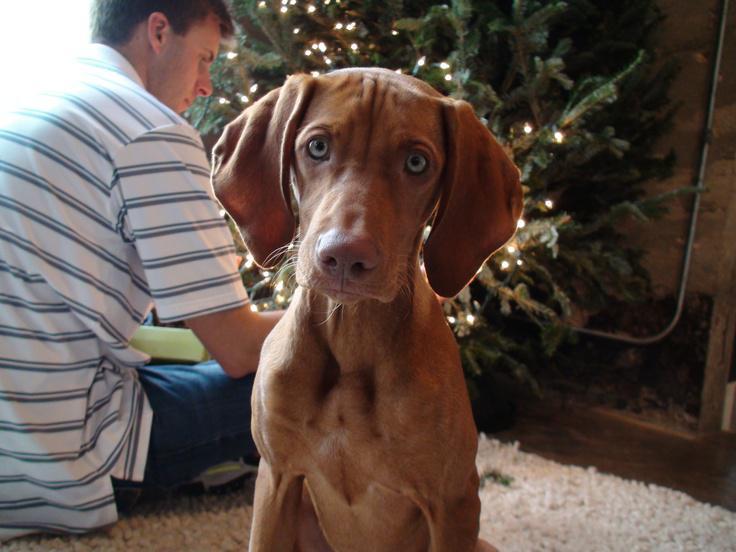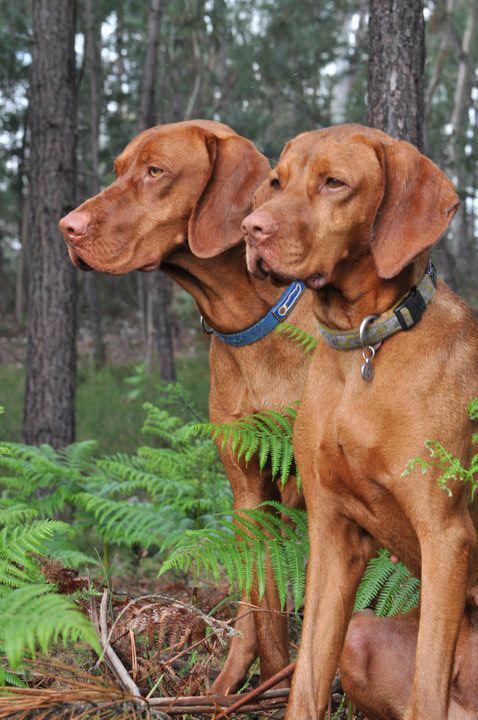The first image is the image on the left, the second image is the image on the right. Given the left and right images, does the statement "There are four dog ears visible." hold true? Answer yes or no. Yes. The first image is the image on the left, the second image is the image on the right. Given the left and right images, does the statement "One image shows a red-orange hound gazing somewhat forward, and the other image includes a left-facing red-orange hound with the front paw closest to the camera raised." hold true? Answer yes or no. No. 